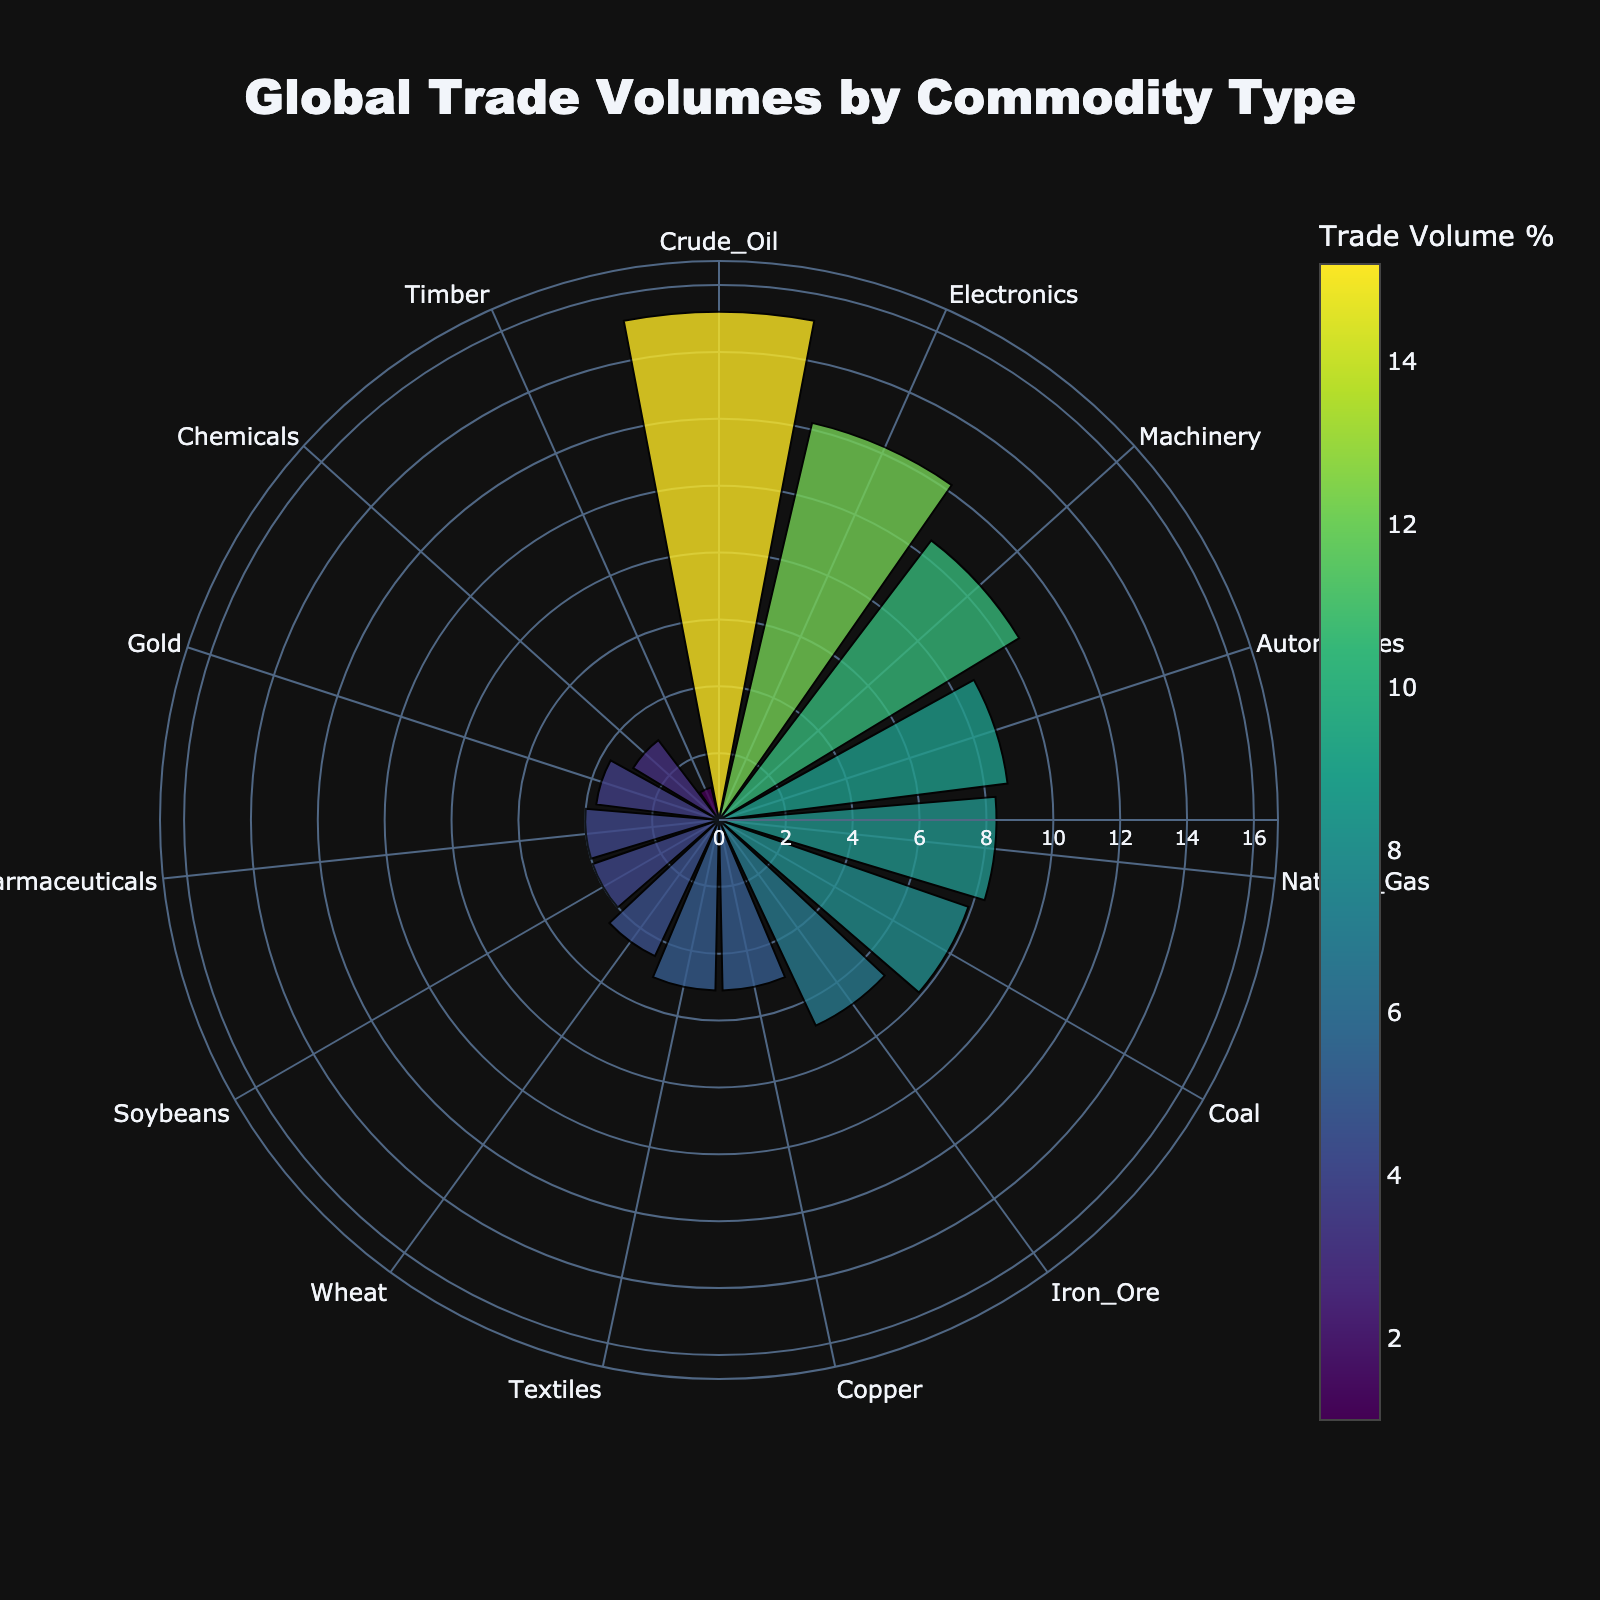what is the title of the figure? The title of the figure is generally located at the top of a chart and displays the main subject or summary of the data presented. In this case, a quick look at the chart will show the title as 'Global Trade Volumes by Commodity Type'.
Answer: Global Trade Volumes by Commodity Type Which commodity has the highest trade volume percentage? To find the commodity with the highest trade volume percentage, check which sector/circular bar extends the furthest from the center. In this case, it's 'Crude Oil' with a trade volume of 15.2%.
Answer: Crude Oil What color represents the commodity with the highest trade volume percentage? Look at the circular bar that extends the furthest from the center, which represents the highest trade volume. The marker color is assigned based on the trade volume percentages and visually represented in the 'Viridis' color scale. For Crude Oil with the highest trade volume of 15.2%, the color is likely a bright yellow hue.
Answer: Bright yellow Which two commodities have the closest trade volume percentages, and what are those percentages? Scan the chart for sectors that appear to have similar lengths. 'Copper' and 'Textiles' both have a trade volume percentage of 5.1%, making them the closest.
Answer: Copper and Textiles, both 5.1% How much larger is the trade volume percentage of Electronics compared to Pharmaceuticals? First, find the trade volume percentages for both Electronics (12.2%) and Pharmaceuticals (4.0%). Subtract the smaller percentage from the larger one to find the difference: 12.2% - 4.0% = 8.2%.
Answer: 8.2% Which commodity has the smallest trade volume percentage and what is it? Identify the sector that is closest to the center, which will be the smallest trade volume percentage. The commodity 'Timber' has the smallest trade volume of 1.0%.
Answer: Timber, 1.0% Order the commodities by trade volume percentage starting from the smallest to the largest. Visual analysis and reading the values from the smallest sector to the largest will give: Timber (1.0%), Chemicals (3.0%), Gold (3.7%), Pharmaceuticals (4.0%), Soybeans (4.0%), Wheat (4.5%), Textiles (5.1%), Copper (5.1%), Iron Ore (6.8%), Coal (7.9%), Natural Gas (8.3%), Automobiles (8.7%), Machinery (10.5%), Electronics (12.2%), Crude Oil (15.2%).
Answer: Timber, Chemicals, Gold, Pharmaceuticals, Soybeans, Wheat, Textiles, Copper, Iron Ore, Coal, Natural Gas, Automobiles, Machinery, Electronics, Crude Oil What's the combined trade volume percentage for all energy-related commodities (Crude Oil, Natural Gas, Coal)? Sum the trade volume percentages for Crude Oil (15.2%), Natural Gas (8.3%), and Coal (7.9%). The combined volume is 15.2% + 8.3% + 7.9% = 31.4%.
Answer: 31.4% In terms of trade volume percentage, how much greater is Crude Oil compared to Coal? The trade volume percentage of Crude Oil is 15.2%, and Coal is 7.9%. Subtract the smaller from the larger to get the difference: 15.2% - 7.9% = 7.3%.
Answer: 7.3% Which commodity type between Natural Gas and Automobiles has a higher trade volume percentage and by how much? Natural Gas has a trade volume percentage of 8.3%, and Automobiles have 8.7%. The difference can be calculated as 8.7% - 8.3% = 0.4%. Therefore, Automobiles have a higher trade volume by 0.4%.
Answer: Automobiles, 0.4% 